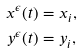Convert formula to latex. <formula><loc_0><loc_0><loc_500><loc_500>x ^ { \epsilon } ( t ) & = x _ { i } , \\ y ^ { \epsilon } ( t ) & = y _ { i } ,</formula> 